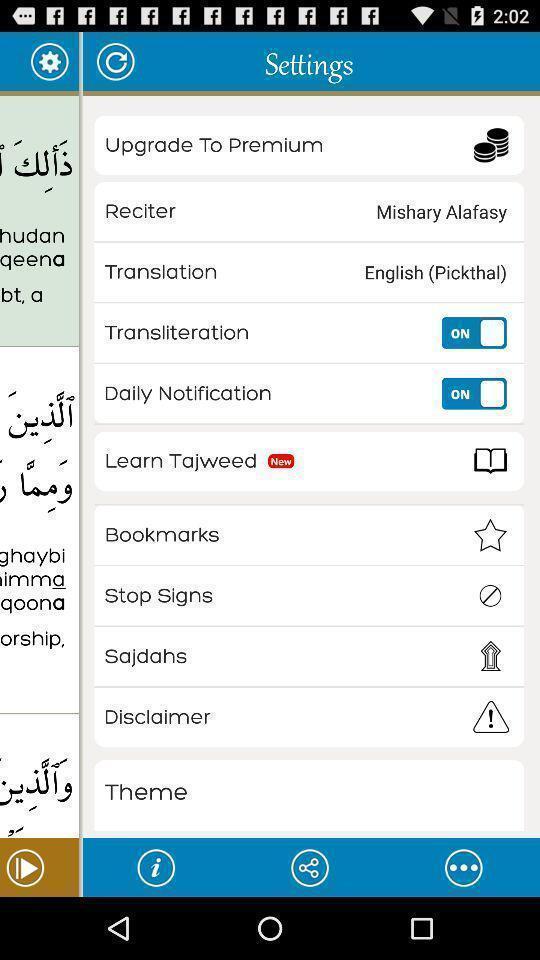Describe the key features of this screenshot. Popup displaying settings information about quran application. 